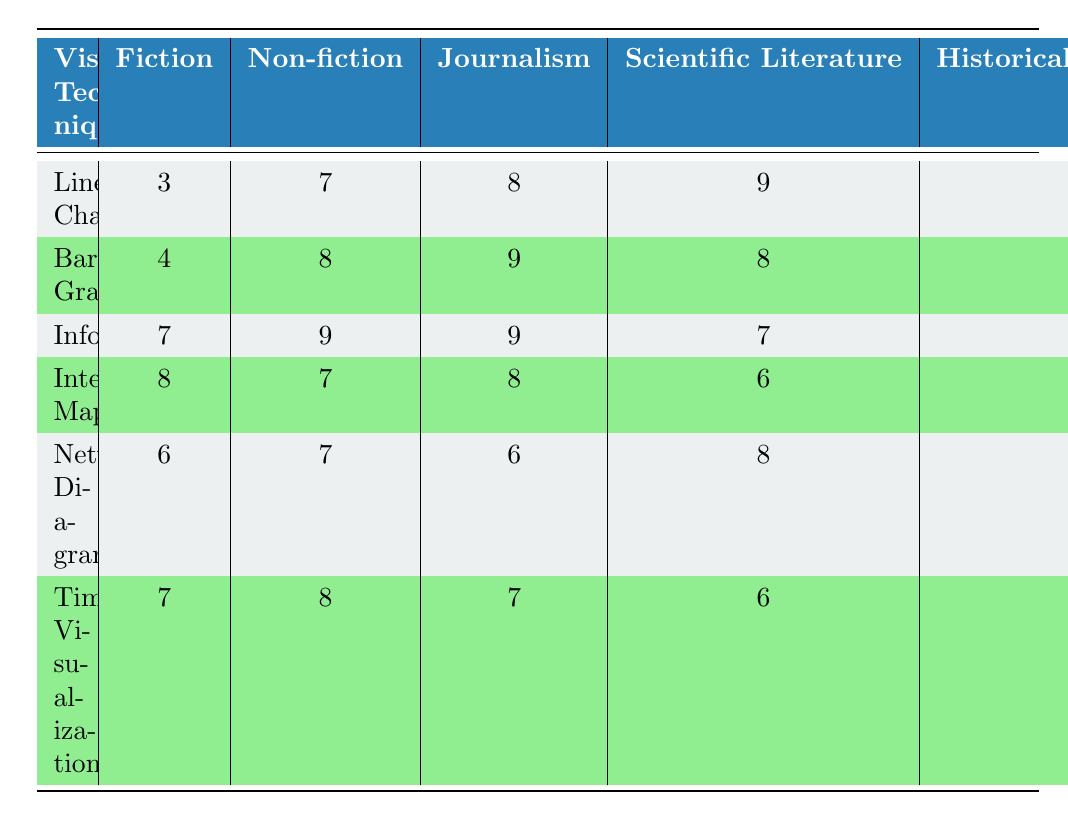What is the effectiveness score of Line Charts in Journalism? The table provides a specific score for each visualization technique across different genres. Looking at the row for Line Charts, we can find the value under the Journalism column, which is 8.
Answer: 8 Which visualization technique has the highest effectiveness score in Non-fiction? In the Non-fiction column, we can compare the effectiveness scores of all the techniques. The maximum value is in the Infographics row, which shows a score of 9.
Answer: Infographics What is the average effectiveness score of Interactive Maps across all genres? To calculate the average, we sum the scores of Interactive Maps across all genres: (8 + 7 + 8 + 6 + 9) = 38. There are 5 genres, so the average is 38 / 5 = 7.6.
Answer: 7.6 Is Timeline Visualizations more effective in Historical Narratives than in Scientific Literature? We compare the scores for Timeline Visualizations in both genres. The score for Historical Narratives is 9, while the score for Scientific Literature is 6. Since 9 is greater than 6, Timeline Visualizations is indeed more effective in Historical Narratives.
Answer: Yes What technique is considered the least effective in Fiction? By inspecting the Fiction column, we can see the scores for each technique. The lowest score is 3 for Line Charts.
Answer: Line Charts Which visualization technique is equally effective in both Journalism and Interactive Maps? By checking the scores in both the Journalism and Interactive Maps columns, we see that the score for both is 8, which indicates that Bar Graphs have the same effectiveness in both cases.
Answer: Bar Graphs What is the difference in effectiveness scores for Infographics and Bar Graphs in Historical Narratives? The effectiveness score for Infographics in Historical Narratives is 8, while for Bar Graphs it is 7. The difference is 8 - 7 = 1.
Answer: 1 Which genre has the lowest effectiveness score for Network Diagrams? Looking at the Network Diagrams row, we see the values: 6 for Fiction, 7 for Non-fiction, 6 for Journalism, 8 for Scientific Literature, and 7 for Historical Narratives. The lowest score is 6, which appears in both Fiction and Journalism.
Answer: Fiction and Journalism What can you conclude about the effectiveness score trend for visualization techniques from Fiction to Scientific Literature? Examining the effectiveness scores from Fiction to Scientific Literature, we find that they are: Line Charts (3), Bar Graphs (4), Infographics (7), Interactive Maps (8), Network Diagrams (6), Timeline Visualizations (7). The trend is mostly inconsistent, with scores fluctuating between highs and lows, indicating that no clear upward or downward trend is present.
Answer: No clear trend 